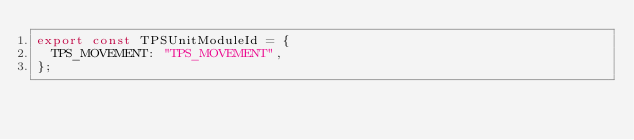<code> <loc_0><loc_0><loc_500><loc_500><_JavaScript_>export const TPSUnitModuleId = {
  TPS_MOVEMENT: "TPS_MOVEMENT",
};
</code> 